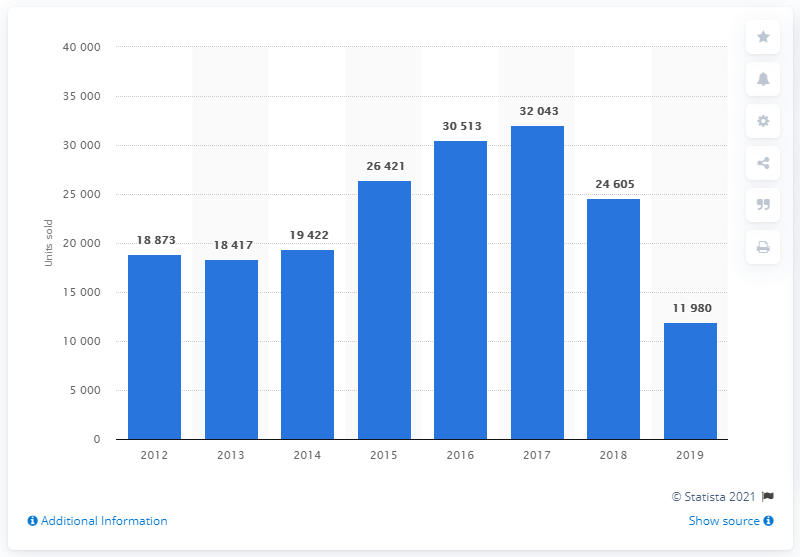Point out several critical features in this image. Last year, Nissan sold a total of 11,980 cars in Turkey. In 2017, Nissan sold the highest number of cars in Turkey with 32,043 units. 